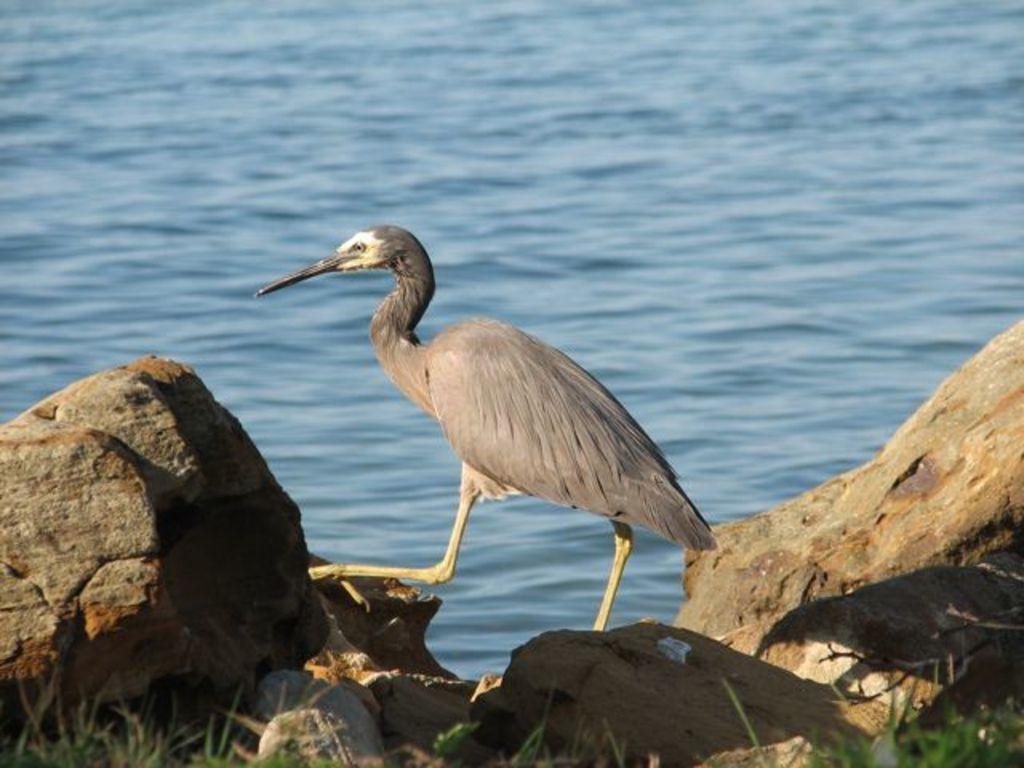Please provide a concise description of this image. This image consists of a bird. It is having a sharp beak. At the bottom, there are rocks along with green grass. In the background, there is water. 